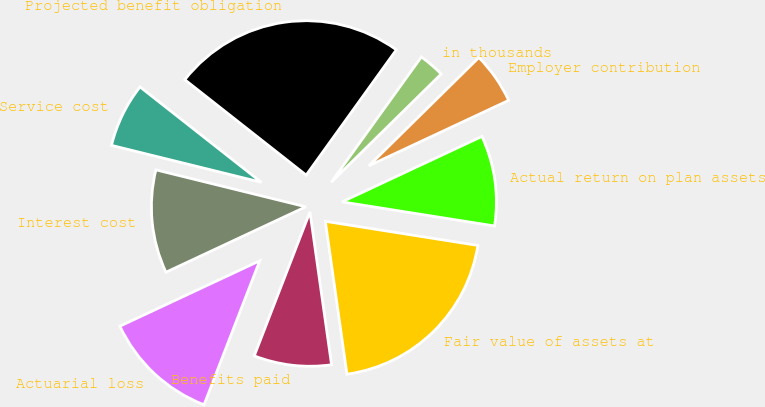Convert chart. <chart><loc_0><loc_0><loc_500><loc_500><pie_chart><fcel>in thousands<fcel>Projected benefit obligation<fcel>Service cost<fcel>Interest cost<fcel>Actuarial loss<fcel>Benefits paid<fcel>Fair value of assets at<fcel>Actual return on plan assets<fcel>Employer contribution<nl><fcel>2.7%<fcel>24.32%<fcel>6.76%<fcel>10.81%<fcel>12.16%<fcel>8.11%<fcel>20.27%<fcel>9.46%<fcel>5.41%<nl></chart> 